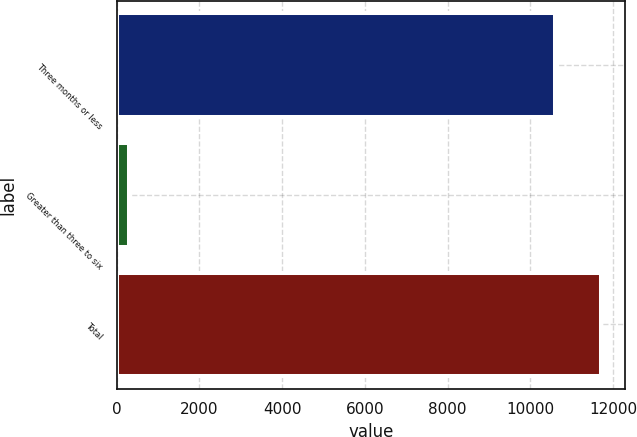Convert chart. <chart><loc_0><loc_0><loc_500><loc_500><bar_chart><fcel>Three months or less<fcel>Greater than three to six<fcel>Total<nl><fcel>10597<fcel>306<fcel>11699.6<nl></chart> 